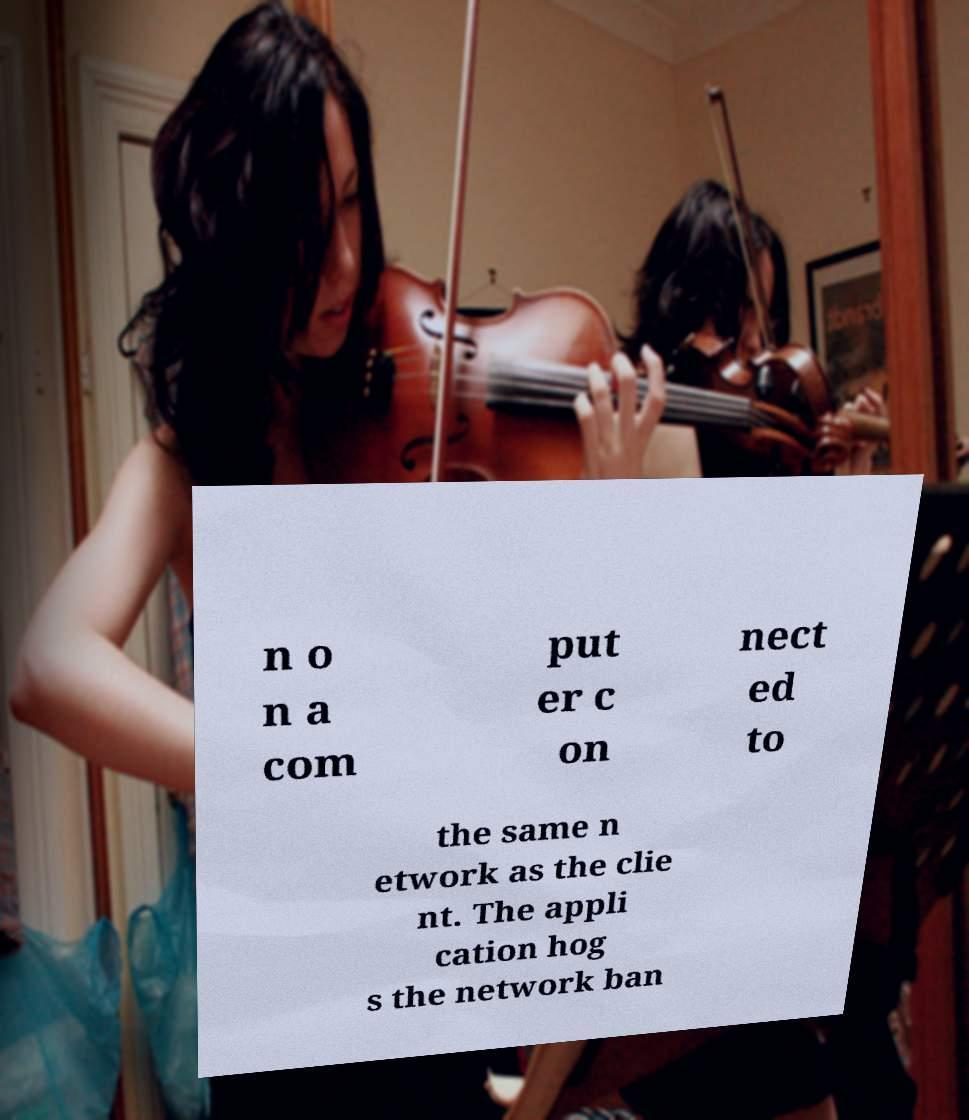There's text embedded in this image that I need extracted. Can you transcribe it verbatim? n o n a com put er c on nect ed to the same n etwork as the clie nt. The appli cation hog s the network ban 